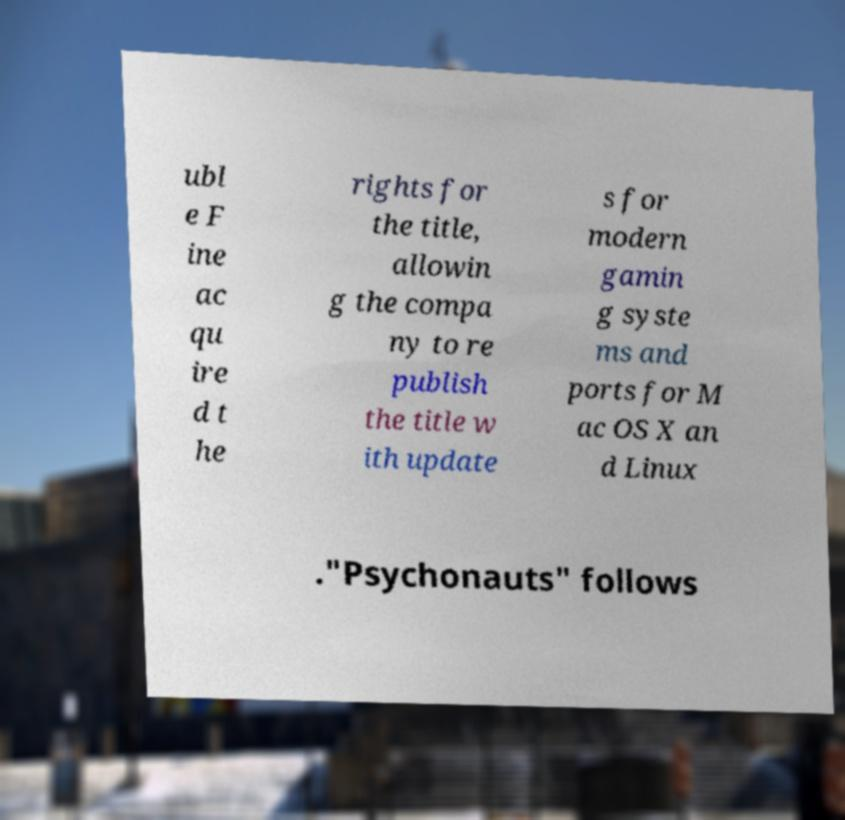Can you read and provide the text displayed in the image?This photo seems to have some interesting text. Can you extract and type it out for me? ubl e F ine ac qu ire d t he rights for the title, allowin g the compa ny to re publish the title w ith update s for modern gamin g syste ms and ports for M ac OS X an d Linux ."Psychonauts" follows 